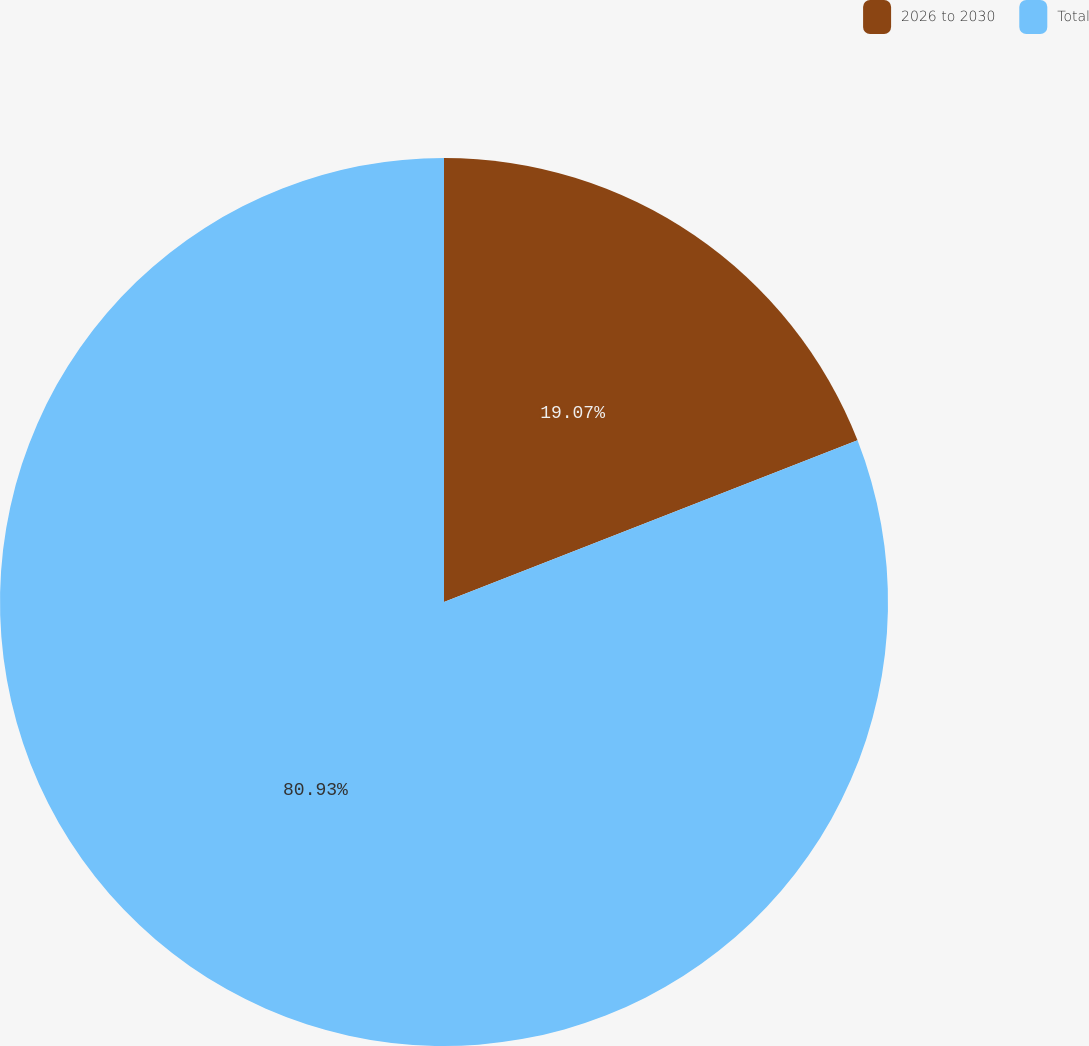Convert chart to OTSL. <chart><loc_0><loc_0><loc_500><loc_500><pie_chart><fcel>2026 to 2030<fcel>Total<nl><fcel>19.07%<fcel>80.93%<nl></chart> 